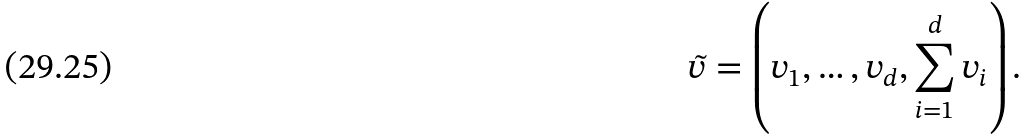<formula> <loc_0><loc_0><loc_500><loc_500>\tilde { v } = \left ( v _ { 1 } , \dots , v _ { d } , \sum _ { i = 1 } ^ { d } v _ { i } \right ) .</formula> 